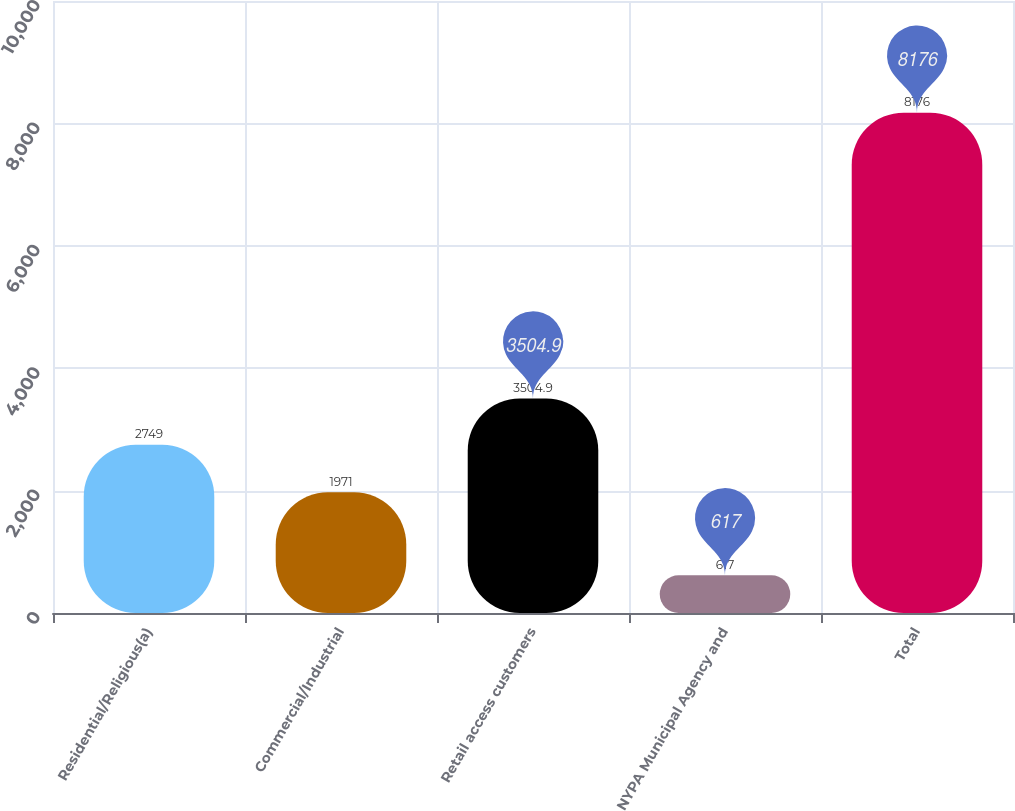Convert chart. <chart><loc_0><loc_0><loc_500><loc_500><bar_chart><fcel>Residential/Religious(a)<fcel>Commercial/Industrial<fcel>Retail access customers<fcel>NYPA Municipal Agency and<fcel>Total<nl><fcel>2749<fcel>1971<fcel>3504.9<fcel>617<fcel>8176<nl></chart> 